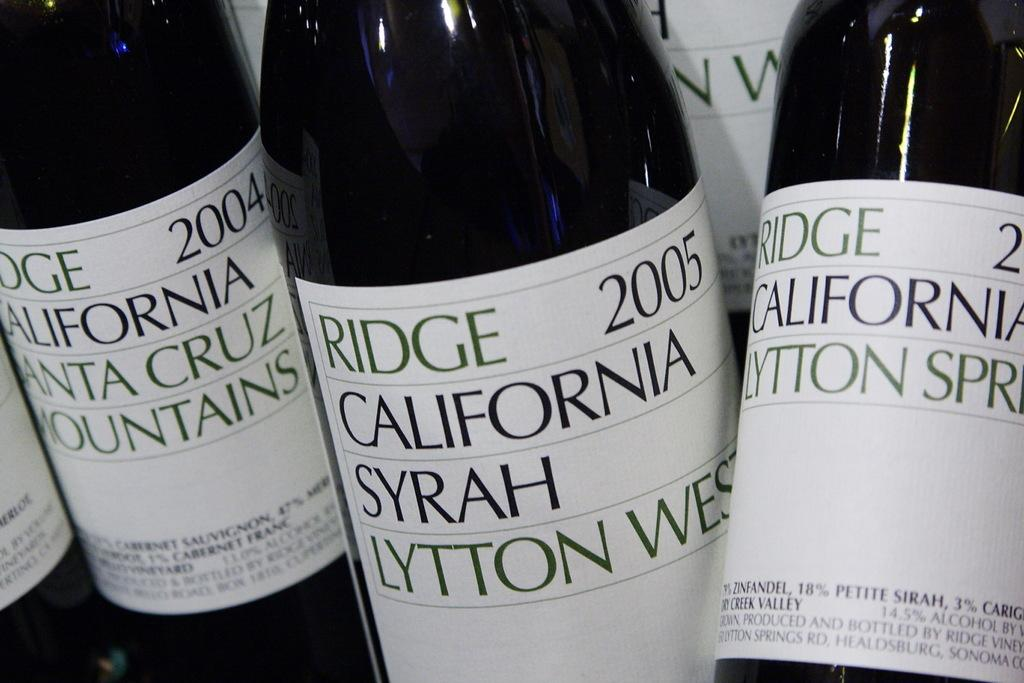<image>
Render a clear and concise summary of the photo. Bottles of wine by Ridge California Syrah Lytton West with 2005 on the label. 